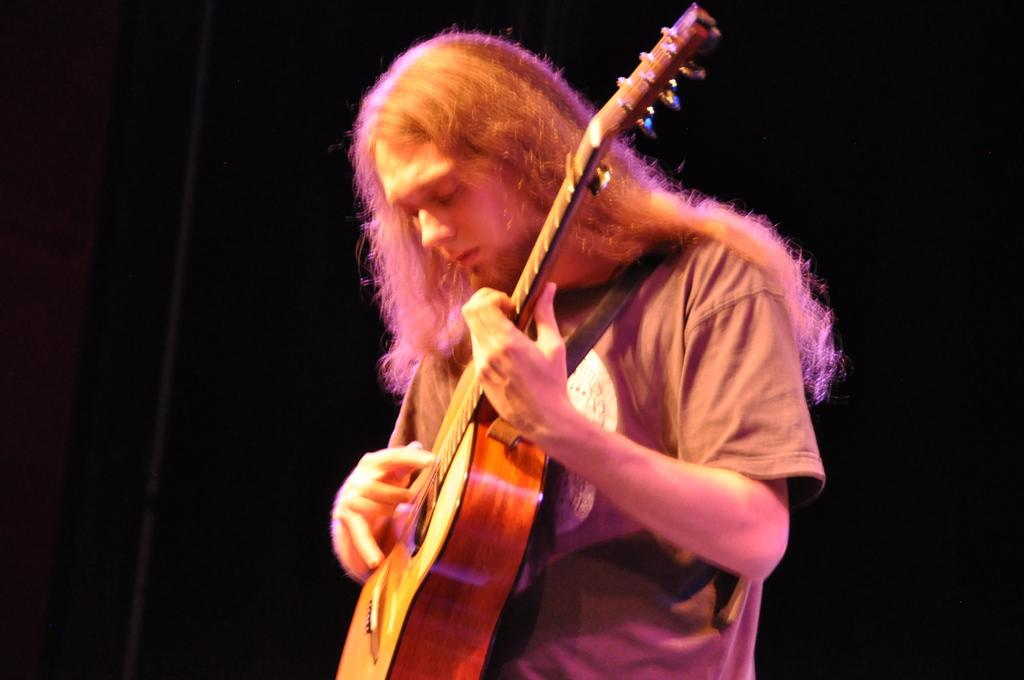Who is the main subject in the image? There is a boy in the image. Can you describe the boy's appearance? The boy has long hair. What is the boy holding in the image? The boy is holding a guitar. What is the boy doing with the guitar? The boy is playing the guitar. What is the color of the background in the image? The background of the image is black. What type of stitch is the boy using to sew a worm in the image? There is no stitch or worm present in the image; the boy is playing a guitar. What type of gun is the boy holding in the image? There is no gun present in the image; the boy is holding a guitar. 